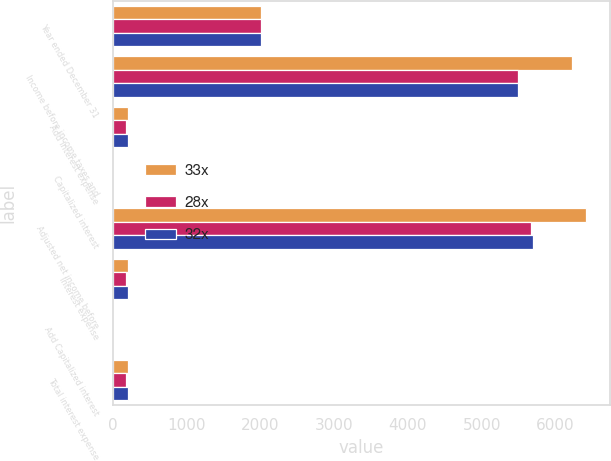Convert chart. <chart><loc_0><loc_0><loc_500><loc_500><stacked_bar_chart><ecel><fcel>Year ended December 31<fcel>Income before income taxes and<fcel>Add Interest expense<fcel>Capitalized interest<fcel>Adjusted net income before<fcel>Interest expense<fcel>Add Capitalized interest<fcel>Total interest expense<nl><fcel>33x<fcel>2004<fcel>6222<fcel>196<fcel>1<fcel>6419<fcel>196<fcel>1<fcel>197<nl><fcel>28x<fcel>2003<fcel>5495<fcel>178<fcel>1<fcel>5674<fcel>178<fcel>1<fcel>179<nl><fcel>32x<fcel>2002<fcel>5499<fcel>199<fcel>1<fcel>5699<fcel>199<fcel>1<fcel>200<nl></chart> 